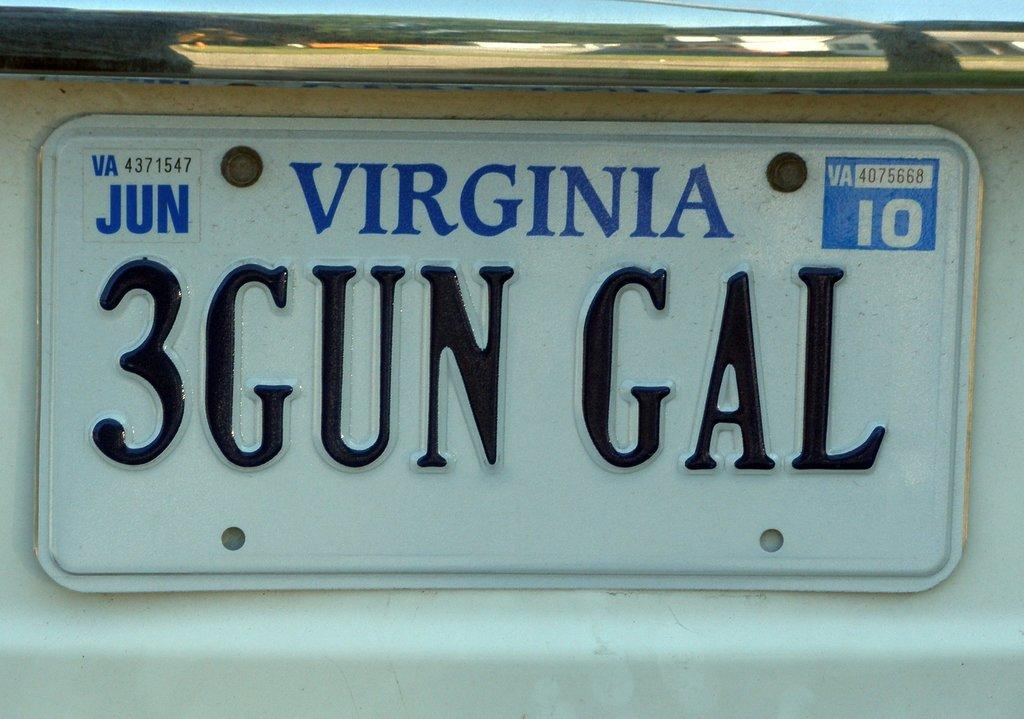<image>
Share a concise interpretation of the image provided. A white, Virginia license plate expires in June. 